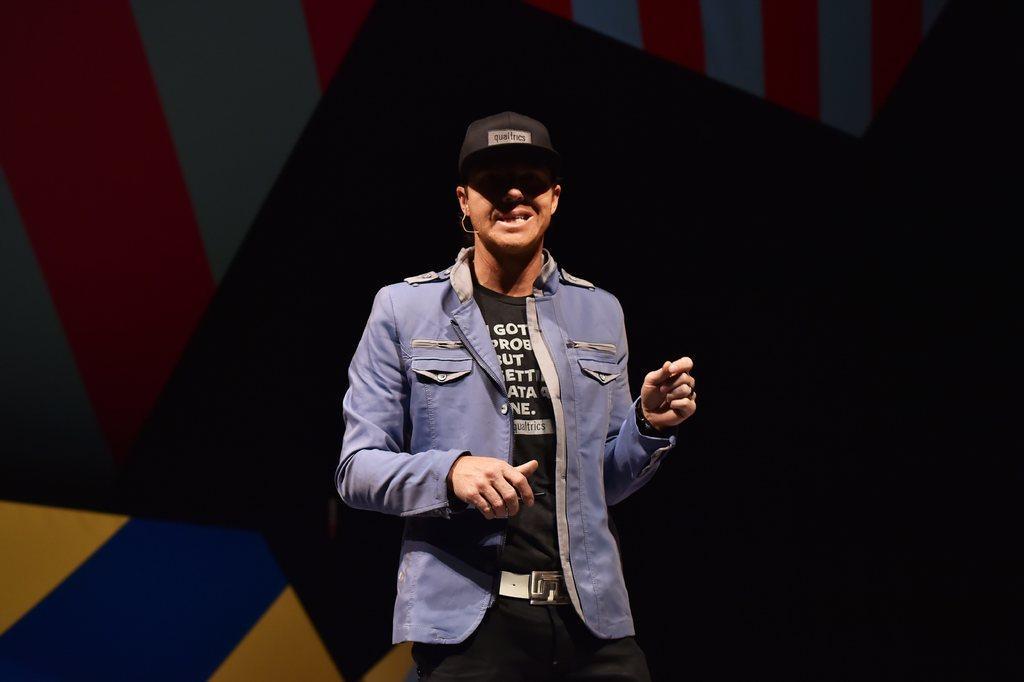Describe this image in one or two sentences. In this image there is a person standing, behind the person there is a wall. 